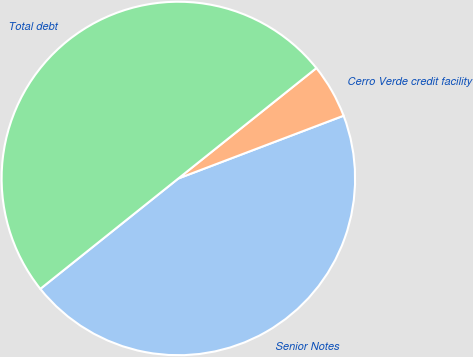Convert chart. <chart><loc_0><loc_0><loc_500><loc_500><pie_chart><fcel>Senior Notes<fcel>Cerro Verde credit facility<fcel>Total debt<nl><fcel>45.04%<fcel>4.96%<fcel>50.0%<nl></chart> 